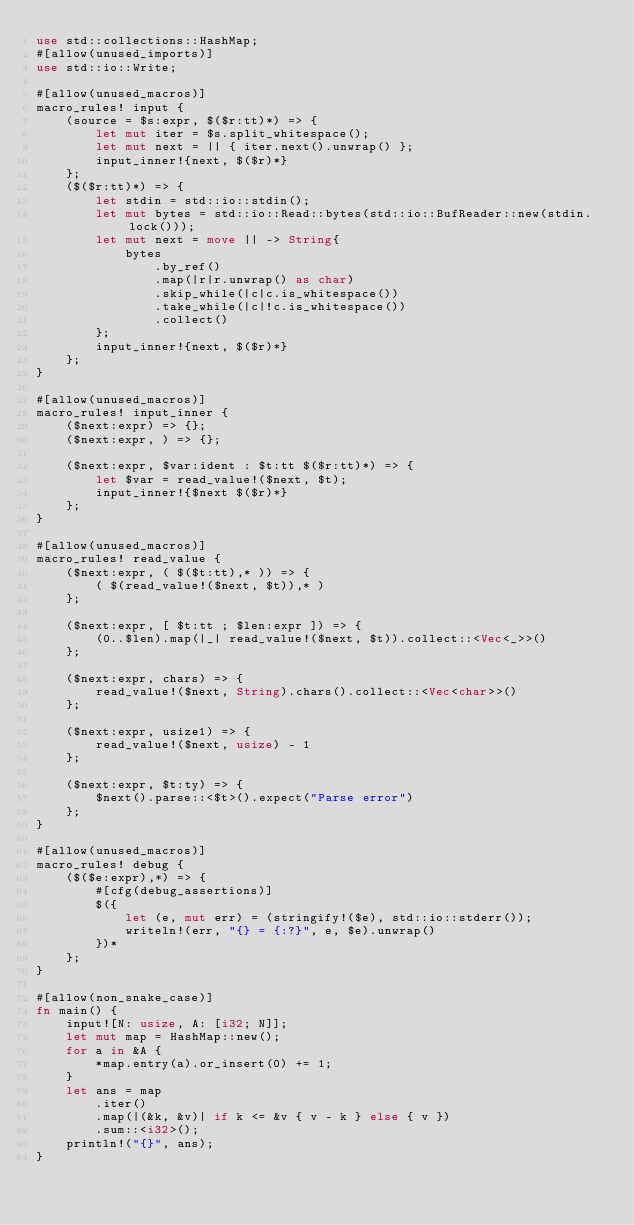<code> <loc_0><loc_0><loc_500><loc_500><_Rust_>use std::collections::HashMap;
#[allow(unused_imports)]
use std::io::Write;

#[allow(unused_macros)]
macro_rules! input {
    (source = $s:expr, $($r:tt)*) => {
        let mut iter = $s.split_whitespace();
        let mut next = || { iter.next().unwrap() };
        input_inner!{next, $($r)*}
    };
    ($($r:tt)*) => {
        let stdin = std::io::stdin();
        let mut bytes = std::io::Read::bytes(std::io::BufReader::new(stdin.lock()));
        let mut next = move || -> String{
            bytes
                .by_ref()
                .map(|r|r.unwrap() as char)
                .skip_while(|c|c.is_whitespace())
                .take_while(|c|!c.is_whitespace())
                .collect()
        };
        input_inner!{next, $($r)*}
    };
}

#[allow(unused_macros)]
macro_rules! input_inner {
    ($next:expr) => {};
    ($next:expr, ) => {};

    ($next:expr, $var:ident : $t:tt $($r:tt)*) => {
        let $var = read_value!($next, $t);
        input_inner!{$next $($r)*}
    };
}

#[allow(unused_macros)]
macro_rules! read_value {
    ($next:expr, ( $($t:tt),* )) => {
        ( $(read_value!($next, $t)),* )
    };

    ($next:expr, [ $t:tt ; $len:expr ]) => {
        (0..$len).map(|_| read_value!($next, $t)).collect::<Vec<_>>()
    };

    ($next:expr, chars) => {
        read_value!($next, String).chars().collect::<Vec<char>>()
    };

    ($next:expr, usize1) => {
        read_value!($next, usize) - 1
    };

    ($next:expr, $t:ty) => {
        $next().parse::<$t>().expect("Parse error")
    };
}

#[allow(unused_macros)]
macro_rules! debug {
    ($($e:expr),*) => {
        #[cfg(debug_assertions)]
        $({
            let (e, mut err) = (stringify!($e), std::io::stderr());
            writeln!(err, "{} = {:?}", e, $e).unwrap()
        })*
    };
}

#[allow(non_snake_case)]
fn main() {
    input![N: usize, A: [i32; N]];
    let mut map = HashMap::new();
    for a in &A {
        *map.entry(a).or_insert(0) += 1;
    }
    let ans = map
        .iter()
        .map(|(&k, &v)| if k <= &v { v - k } else { v })
        .sum::<i32>();
    println!("{}", ans);
}
</code> 